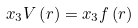Convert formula to latex. <formula><loc_0><loc_0><loc_500><loc_500>x _ { 3 } V \left ( r \right ) = x _ { 3 } f \left ( r \right )</formula> 